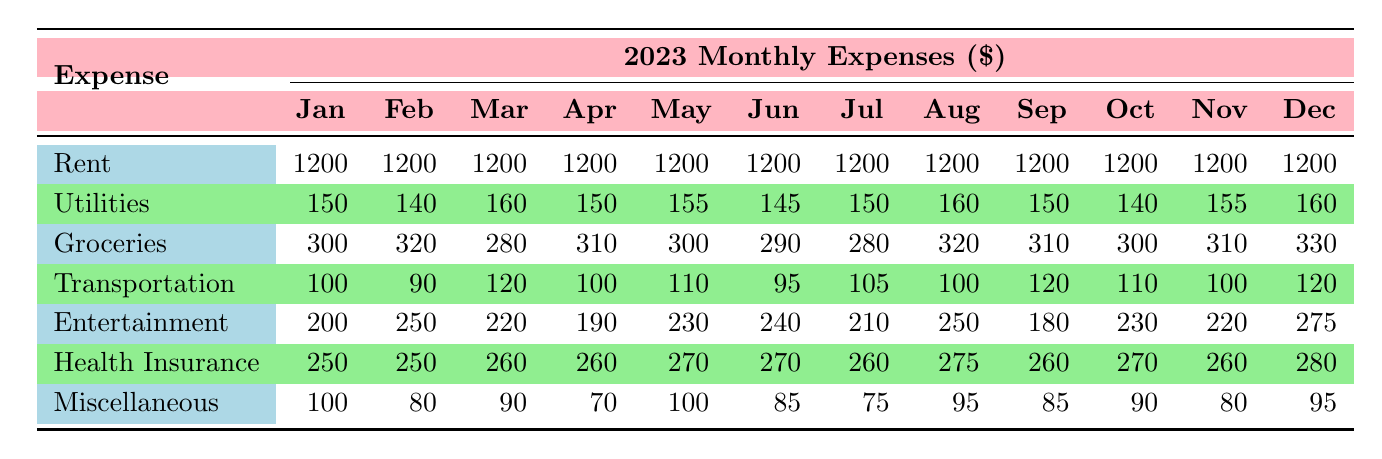What was Jody's highest monthly expense on entertainment in 2023? In reviewing the table, the column for Entertainment shows monthly expenses ranging between 190 and 275. The highest value observed is 275 in December.
Answer: 275 What was the total rent paid from January to December in 2023? Jody's rent stays constant at 1200 per month. Since there are 12 months, the total rent is calculated as 1200 multiplied by 12, which equals 14400.
Answer: 14400 Did Jody's utilities expenses increase in February compared to January? In January, utilities are 150 and in February they are 140. Since 140 is less than 150, the expenses did not increase.
Answer: No What is the average monthly cost of groceries for Jody in 2023? The grocery expenses are 300, 320, 280, 310, 300, 290, 280, 320, 310, 300, 310, and 330. Adding these gives 3670. Dividing by the number of months, which is 12, yields an average of about 305.83.
Answer: 305.83 In which month did Jody spend the least on miscellaneous expenses? By reviewing the Miscellaneous row, the least amount recorded is 70 in April.
Answer: April Which month had the highest total of personal expenses? To find the month with the highest total, we sum the expenses for each month: January (1200 + 150 + 300 + 100 + 200 + 250 + 100 = 2100), February (1200 + 140 + 320 + 90 + 250 + 250 + 80 = 2120), and so on for each month. The totals reveal that December, with a total of 2585, is the highest expense month.
Answer: December Was Jody's transportation expense ever the same in two different months? Checking the Transportation row, we find that the expenses are: 100, 90, 120, 100, 110, 95, 105, 100, 120, 110, 100, and 120. The value of 100 appears in January, April, July, and October. Thus, there are months with the same transportation expense.
Answer: Yes What was the increase in health insurance expenses from January to December? The expenses for Health Insurance are 250 in January and 280 in December. The increase is calculated as 280 - 250, which equals 30.
Answer: 30 How much did Jody spend on groceries in the month of August? Referring to the Groceries row for August, the expense recorded is 320.
Answer: 320 